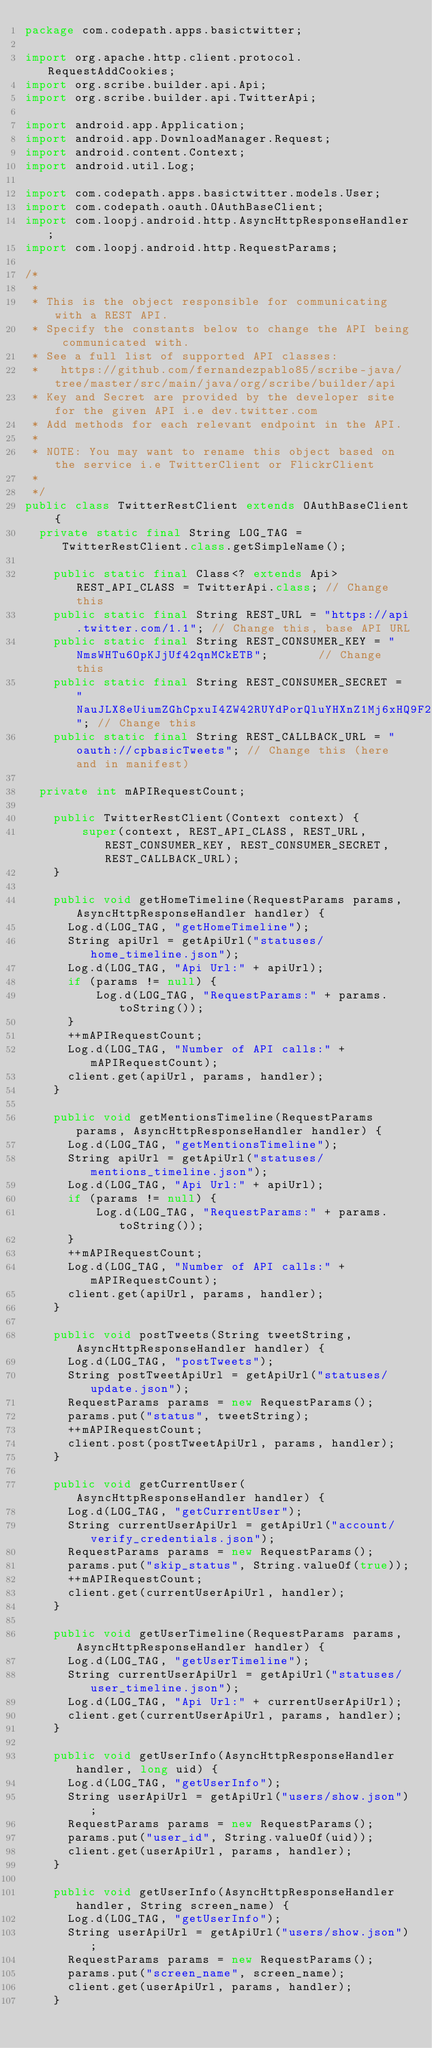<code> <loc_0><loc_0><loc_500><loc_500><_Java_>package com.codepath.apps.basictwitter;

import org.apache.http.client.protocol.RequestAddCookies;
import org.scribe.builder.api.Api;
import org.scribe.builder.api.TwitterApi;

import android.app.Application;
import android.app.DownloadManager.Request;
import android.content.Context;
import android.util.Log;

import com.codepath.apps.basictwitter.models.User;
import com.codepath.oauth.OAuthBaseClient;
import com.loopj.android.http.AsyncHttpResponseHandler;
import com.loopj.android.http.RequestParams;

/*
 * 
 * This is the object responsible for communicating with a REST API. 
 * Specify the constants below to change the API being communicated with.
 * See a full list of supported API classes: 
 *   https://github.com/fernandezpablo85/scribe-java/tree/master/src/main/java/org/scribe/builder/api
 * Key and Secret are provided by the developer site for the given API i.e dev.twitter.com
 * Add methods for each relevant endpoint in the API.
 * 
 * NOTE: You may want to rename this object based on the service i.e TwitterClient or FlickrClient
 * 
 */
public class TwitterRestClient extends OAuthBaseClient {
	private static final String LOG_TAG = TwitterRestClient.class.getSimpleName();
	
    public static final Class<? extends Api> REST_API_CLASS = TwitterApi.class; // Change this
    public static final String REST_URL = "https://api.twitter.com/1.1"; // Change this, base API URL
    public static final String REST_CONSUMER_KEY = "NmsWHTu6OpKJjUf42qnMCkETB";       // Change this
    public static final String REST_CONSUMER_SECRET = "NauJLX8eUiumZGhCpxuI4ZW42RUYdPorQluYHXnZ1Mj6xHQ9F2"; // Change this
    public static final String REST_CALLBACK_URL = "oauth://cpbasicTweets"; // Change this (here and in manifest)
    
	private int mAPIRequestCount;
    
    public TwitterRestClient(Context context) {
        super(context, REST_API_CLASS, REST_URL, REST_CONSUMER_KEY, REST_CONSUMER_SECRET, REST_CALLBACK_URL);
    }
    
    public void getHomeTimeline(RequestParams params, AsyncHttpResponseHandler handler) {
    	Log.d(LOG_TAG, "getHomeTimeline");
    	String apiUrl = getApiUrl("statuses/home_timeline.json");
    	Log.d(LOG_TAG, "Api Url:" + apiUrl);
    	if (params != null) {
    	    Log.d(LOG_TAG, "RequestParams:" + params.toString());
    	}
    	++mAPIRequestCount;
    	Log.d(LOG_TAG, "Number of API calls:" + mAPIRequestCount);
    	client.get(apiUrl, params, handler);
    }
    
    public void getMentionsTimeline(RequestParams params, AsyncHttpResponseHandler handler) {
    	Log.d(LOG_TAG, "getMentionsTimeline");
    	String apiUrl = getApiUrl("statuses/mentions_timeline.json");
    	Log.d(LOG_TAG, "Api Url:" + apiUrl);
    	if (params != null) {
    	    Log.d(LOG_TAG, "RequestParams:" + params.toString());
    	}
    	++mAPIRequestCount;
    	Log.d(LOG_TAG, "Number of API calls:" + mAPIRequestCount);
    	client.get(apiUrl, params, handler);
    }
    
    public void postTweets(String tweetString, AsyncHttpResponseHandler handler) {
    	Log.d(LOG_TAG, "postTweets");
    	String postTweetApiUrl = getApiUrl("statuses/update.json");
    	RequestParams params = new RequestParams();
    	params.put("status", tweetString);
    	++mAPIRequestCount;
    	client.post(postTweetApiUrl, params, handler);
    }
    
    public void getCurrentUser(AsyncHttpResponseHandler handler) {
    	Log.d(LOG_TAG, "getCurrentUser");
    	String currentUserApiUrl = getApiUrl("account/verify_credentials.json");
    	RequestParams params = new RequestParams();
    	params.put("skip_status", String.valueOf(true));
    	++mAPIRequestCount;
    	client.get(currentUserApiUrl, handler);
    }
    
    public void getUserTimeline(RequestParams params, AsyncHttpResponseHandler handler) {
    	Log.d(LOG_TAG, "getUserTimeline");
    	String currentUserApiUrl = getApiUrl("statuses/user_timeline.json");
    	Log.d(LOG_TAG, "Api Url:" + currentUserApiUrl);
    	client.get(currentUserApiUrl, params, handler);
    }
    
    public void getUserInfo(AsyncHttpResponseHandler handler, long uid) {
    	Log.d(LOG_TAG, "getUserInfo");
    	String userApiUrl = getApiUrl("users/show.json");
    	RequestParams params = new RequestParams();
    	params.put("user_id", String.valueOf(uid));
    	client.get(userApiUrl, params, handler);
    }
    
    public void getUserInfo(AsyncHttpResponseHandler handler, String screen_name) {
    	Log.d(LOG_TAG, "getUserInfo");
    	String userApiUrl = getApiUrl("users/show.json");
    	RequestParams params = new RequestParams();
    	params.put("screen_name", screen_name);
    	client.get(userApiUrl, params, handler);
    }
    </code> 